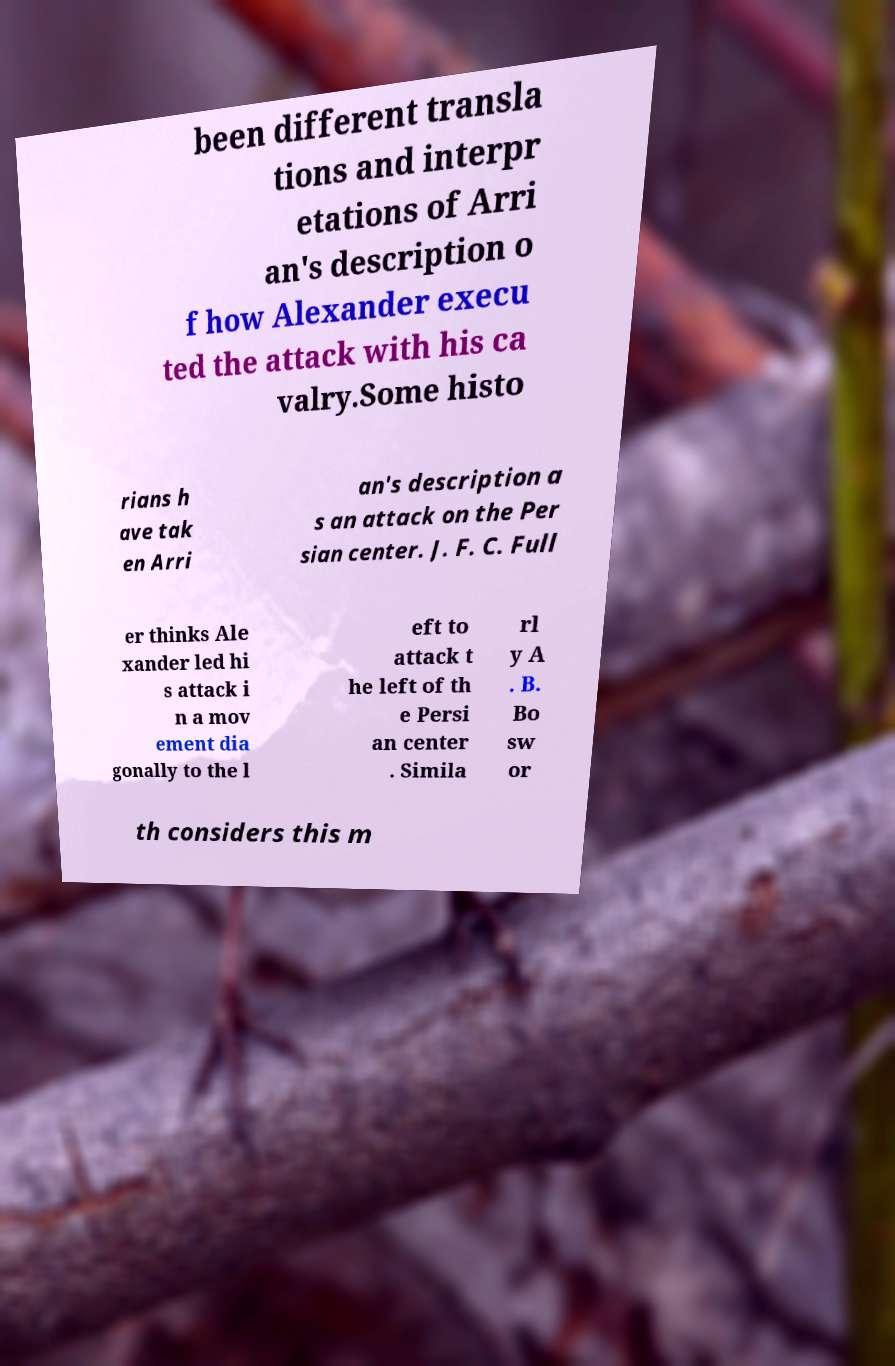Can you read and provide the text displayed in the image?This photo seems to have some interesting text. Can you extract and type it out for me? been different transla tions and interpr etations of Arri an's description o f how Alexander execu ted the attack with his ca valry.Some histo rians h ave tak en Arri an's description a s an attack on the Per sian center. J. F. C. Full er thinks Ale xander led hi s attack i n a mov ement dia gonally to the l eft to attack t he left of th e Persi an center . Simila rl y A . B. Bo sw or th considers this m 